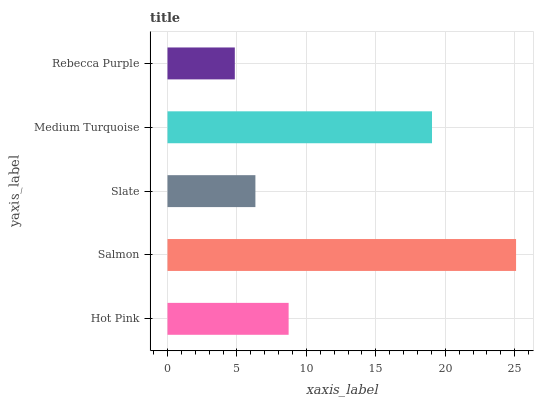Is Rebecca Purple the minimum?
Answer yes or no. Yes. Is Salmon the maximum?
Answer yes or no. Yes. Is Slate the minimum?
Answer yes or no. No. Is Slate the maximum?
Answer yes or no. No. Is Salmon greater than Slate?
Answer yes or no. Yes. Is Slate less than Salmon?
Answer yes or no. Yes. Is Slate greater than Salmon?
Answer yes or no. No. Is Salmon less than Slate?
Answer yes or no. No. Is Hot Pink the high median?
Answer yes or no. Yes. Is Hot Pink the low median?
Answer yes or no. Yes. Is Slate the high median?
Answer yes or no. No. Is Medium Turquoise the low median?
Answer yes or no. No. 